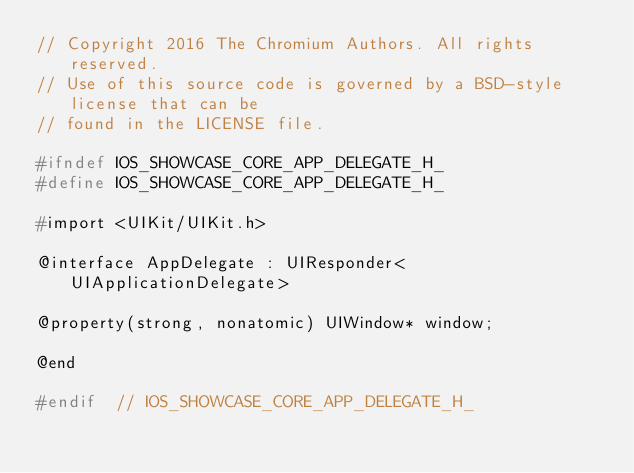Convert code to text. <code><loc_0><loc_0><loc_500><loc_500><_C_>// Copyright 2016 The Chromium Authors. All rights reserved.
// Use of this source code is governed by a BSD-style license that can be
// found in the LICENSE file.

#ifndef IOS_SHOWCASE_CORE_APP_DELEGATE_H_
#define IOS_SHOWCASE_CORE_APP_DELEGATE_H_

#import <UIKit/UIKit.h>

@interface AppDelegate : UIResponder<UIApplicationDelegate>

@property(strong, nonatomic) UIWindow* window;

@end

#endif  // IOS_SHOWCASE_CORE_APP_DELEGATE_H_
</code> 